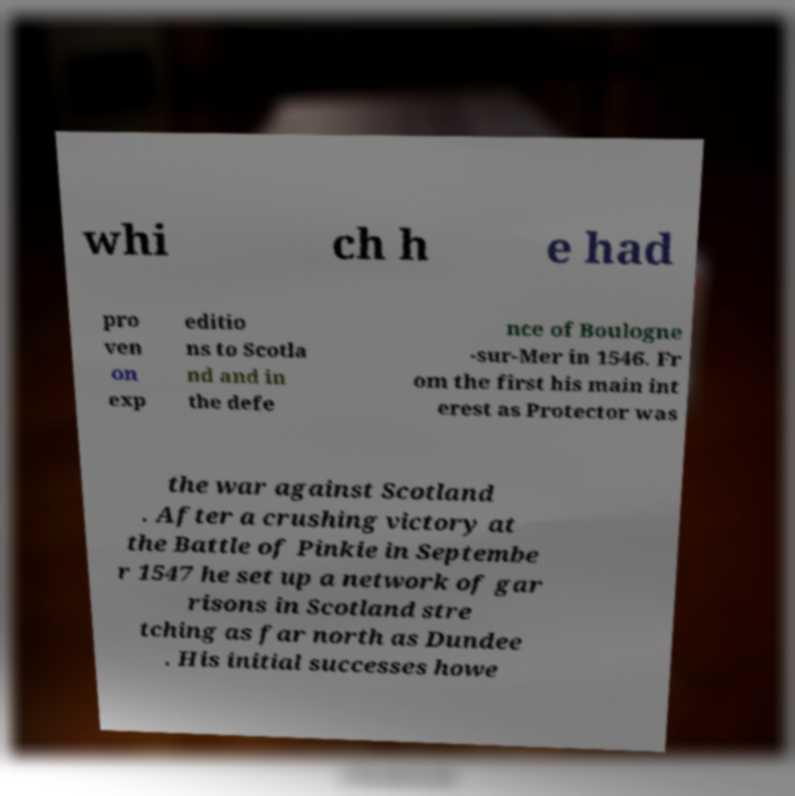What messages or text are displayed in this image? I need them in a readable, typed format. whi ch h e had pro ven on exp editio ns to Scotla nd and in the defe nce of Boulogne -sur-Mer in 1546. Fr om the first his main int erest as Protector was the war against Scotland . After a crushing victory at the Battle of Pinkie in Septembe r 1547 he set up a network of gar risons in Scotland stre tching as far north as Dundee . His initial successes howe 